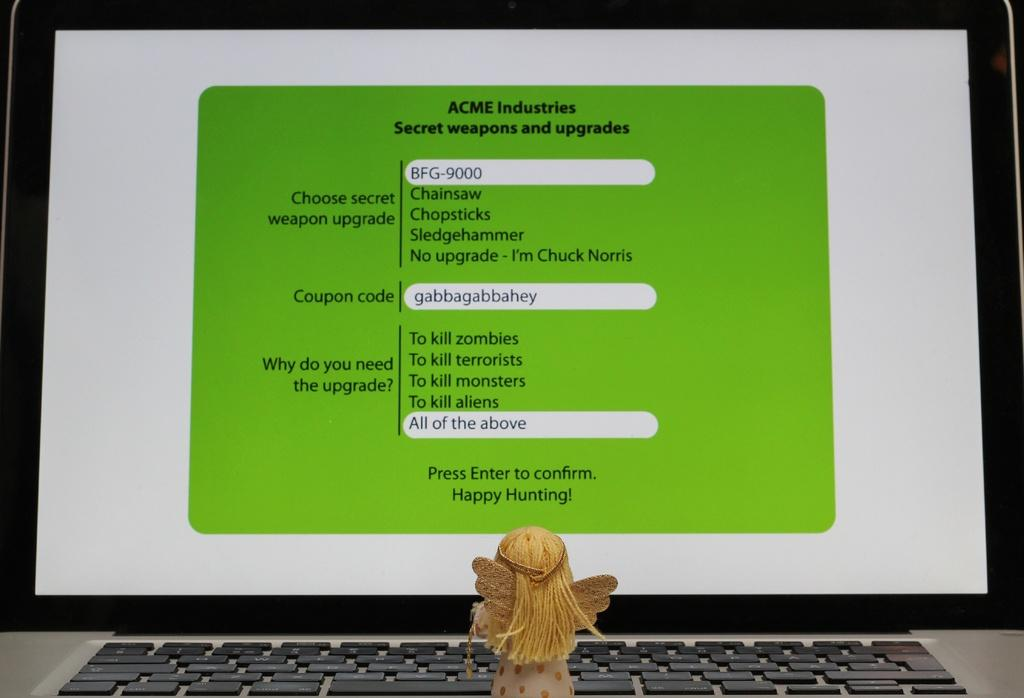<image>
Provide a brief description of the given image. A computer monitor with the title Acme Industries. 